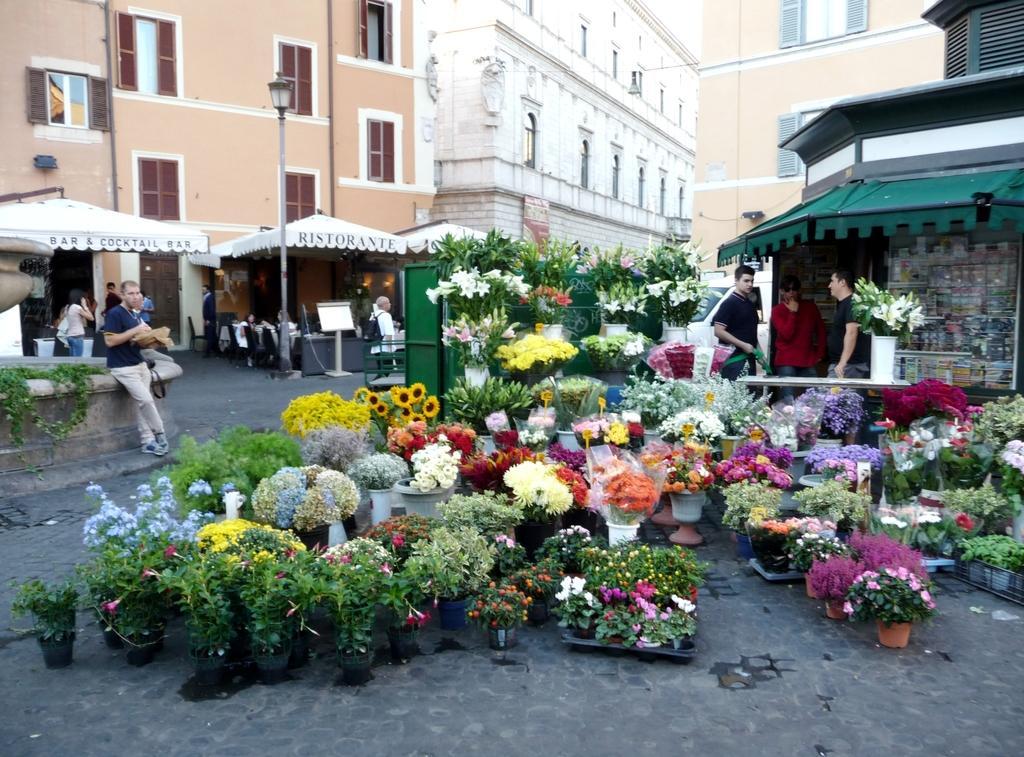How would you summarize this image in a sentence or two? In this image I can see few buildings,windows,light pole,tents,few colorful flowers,flower pots,vehicle,few people are sitting on chairs and few are standing. 